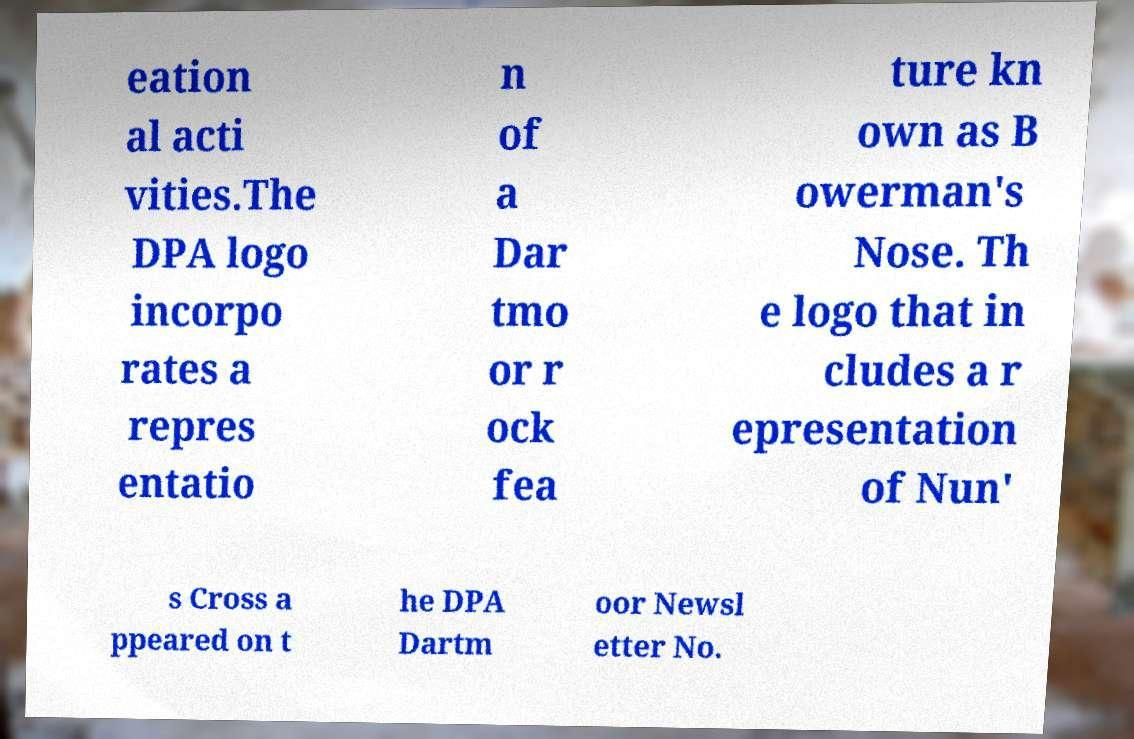For documentation purposes, I need the text within this image transcribed. Could you provide that? eation al acti vities.The DPA logo incorpo rates a repres entatio n of a Dar tmo or r ock fea ture kn own as B owerman's Nose. Th e logo that in cludes a r epresentation of Nun' s Cross a ppeared on t he DPA Dartm oor Newsl etter No. 